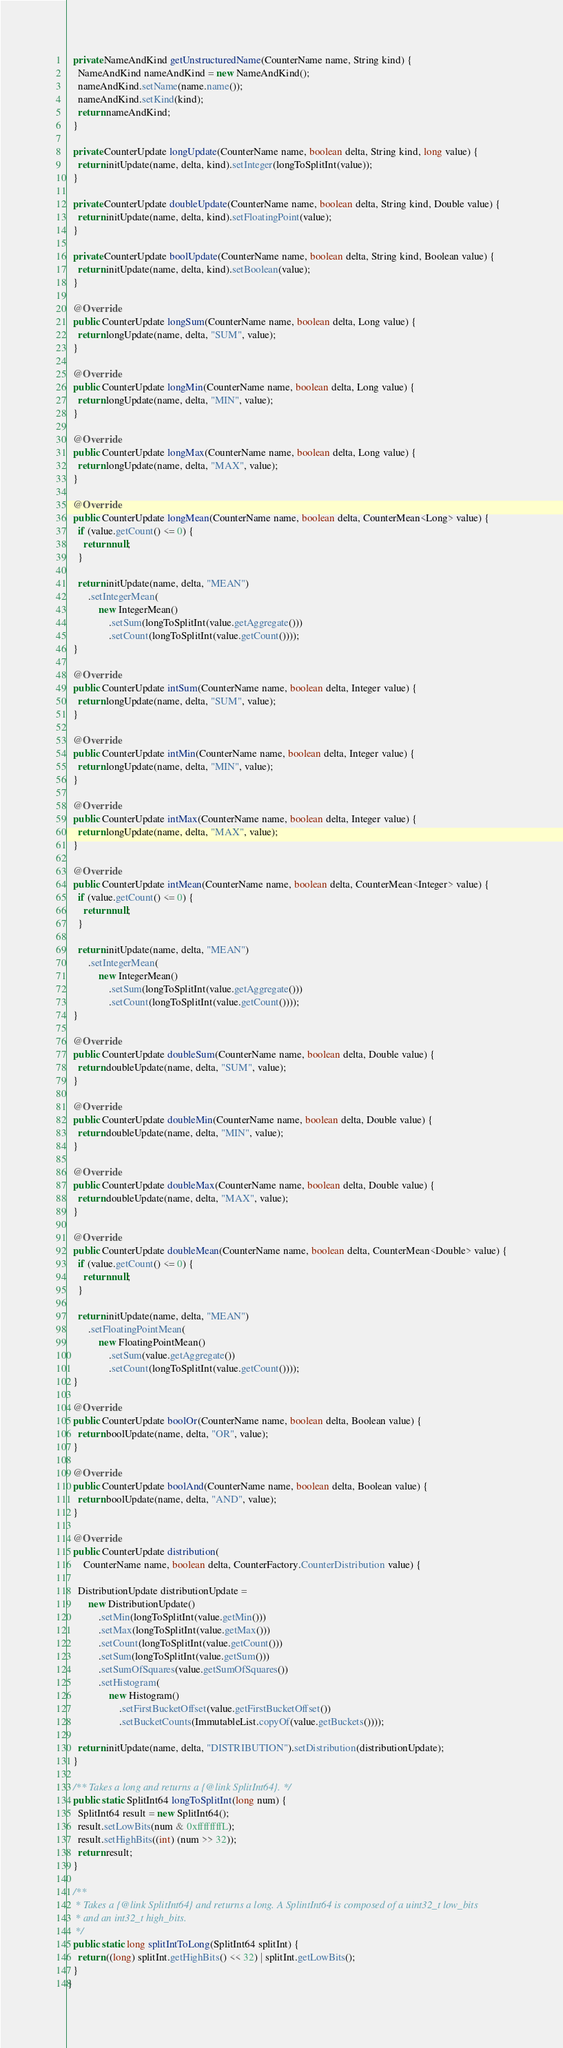<code> <loc_0><loc_0><loc_500><loc_500><_Java_>  private NameAndKind getUnstructuredName(CounterName name, String kind) {
    NameAndKind nameAndKind = new NameAndKind();
    nameAndKind.setName(name.name());
    nameAndKind.setKind(kind);
    return nameAndKind;
  }

  private CounterUpdate longUpdate(CounterName name, boolean delta, String kind, long value) {
    return initUpdate(name, delta, kind).setInteger(longToSplitInt(value));
  }

  private CounterUpdate doubleUpdate(CounterName name, boolean delta, String kind, Double value) {
    return initUpdate(name, delta, kind).setFloatingPoint(value);
  }

  private CounterUpdate boolUpdate(CounterName name, boolean delta, String kind, Boolean value) {
    return initUpdate(name, delta, kind).setBoolean(value);
  }

  @Override
  public CounterUpdate longSum(CounterName name, boolean delta, Long value) {
    return longUpdate(name, delta, "SUM", value);
  }

  @Override
  public CounterUpdate longMin(CounterName name, boolean delta, Long value) {
    return longUpdate(name, delta, "MIN", value);
  }

  @Override
  public CounterUpdate longMax(CounterName name, boolean delta, Long value) {
    return longUpdate(name, delta, "MAX", value);
  }

  @Override
  public CounterUpdate longMean(CounterName name, boolean delta, CounterMean<Long> value) {
    if (value.getCount() <= 0) {
      return null;
    }

    return initUpdate(name, delta, "MEAN")
        .setIntegerMean(
            new IntegerMean()
                .setSum(longToSplitInt(value.getAggregate()))
                .setCount(longToSplitInt(value.getCount())));
  }

  @Override
  public CounterUpdate intSum(CounterName name, boolean delta, Integer value) {
    return longUpdate(name, delta, "SUM", value);
  }

  @Override
  public CounterUpdate intMin(CounterName name, boolean delta, Integer value) {
    return longUpdate(name, delta, "MIN", value);
  }

  @Override
  public CounterUpdate intMax(CounterName name, boolean delta, Integer value) {
    return longUpdate(name, delta, "MAX", value);
  }

  @Override
  public CounterUpdate intMean(CounterName name, boolean delta, CounterMean<Integer> value) {
    if (value.getCount() <= 0) {
      return null;
    }

    return initUpdate(name, delta, "MEAN")
        .setIntegerMean(
            new IntegerMean()
                .setSum(longToSplitInt(value.getAggregate()))
                .setCount(longToSplitInt(value.getCount())));
  }

  @Override
  public CounterUpdate doubleSum(CounterName name, boolean delta, Double value) {
    return doubleUpdate(name, delta, "SUM", value);
  }

  @Override
  public CounterUpdate doubleMin(CounterName name, boolean delta, Double value) {
    return doubleUpdate(name, delta, "MIN", value);
  }

  @Override
  public CounterUpdate doubleMax(CounterName name, boolean delta, Double value) {
    return doubleUpdate(name, delta, "MAX", value);
  }

  @Override
  public CounterUpdate doubleMean(CounterName name, boolean delta, CounterMean<Double> value) {
    if (value.getCount() <= 0) {
      return null;
    }

    return initUpdate(name, delta, "MEAN")
        .setFloatingPointMean(
            new FloatingPointMean()
                .setSum(value.getAggregate())
                .setCount(longToSplitInt(value.getCount())));
  }

  @Override
  public CounterUpdate boolOr(CounterName name, boolean delta, Boolean value) {
    return boolUpdate(name, delta, "OR", value);
  }

  @Override
  public CounterUpdate boolAnd(CounterName name, boolean delta, Boolean value) {
    return boolUpdate(name, delta, "AND", value);
  }

  @Override
  public CounterUpdate distribution(
      CounterName name, boolean delta, CounterFactory.CounterDistribution value) {

    DistributionUpdate distributionUpdate =
        new DistributionUpdate()
            .setMin(longToSplitInt(value.getMin()))
            .setMax(longToSplitInt(value.getMax()))
            .setCount(longToSplitInt(value.getCount()))
            .setSum(longToSplitInt(value.getSum()))
            .setSumOfSquares(value.getSumOfSquares())
            .setHistogram(
                new Histogram()
                    .setFirstBucketOffset(value.getFirstBucketOffset())
                    .setBucketCounts(ImmutableList.copyOf(value.getBuckets())));

    return initUpdate(name, delta, "DISTRIBUTION").setDistribution(distributionUpdate);
  }

  /** Takes a long and returns a {@link SplitInt64}. */
  public static SplitInt64 longToSplitInt(long num) {
    SplitInt64 result = new SplitInt64();
    result.setLowBits(num & 0xffffffffL);
    result.setHighBits((int) (num >> 32));
    return result;
  }

  /**
   * Takes a {@link SplitInt64} and returns a long. A SplintInt64 is composed of a uint32_t low_bits
   * and an int32_t high_bits.
   */
  public static long splitIntToLong(SplitInt64 splitInt) {
    return ((long) splitInt.getHighBits() << 32) | splitInt.getLowBits();
  }
}
</code> 